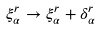<formula> <loc_0><loc_0><loc_500><loc_500>\xi ^ { r } _ { \alpha } \to \xi ^ { r } _ { \alpha } + \delta ^ { r } _ { \alpha }</formula> 